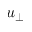<formula> <loc_0><loc_0><loc_500><loc_500>u _ { \perp }</formula> 